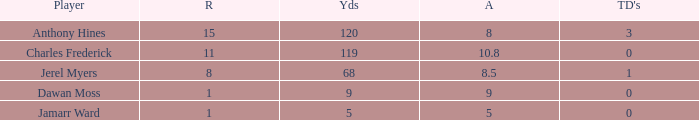What is the average number of TDs when the yards are less than 119, the AVG is larger than 5, and Jamarr Ward is a player? None. 